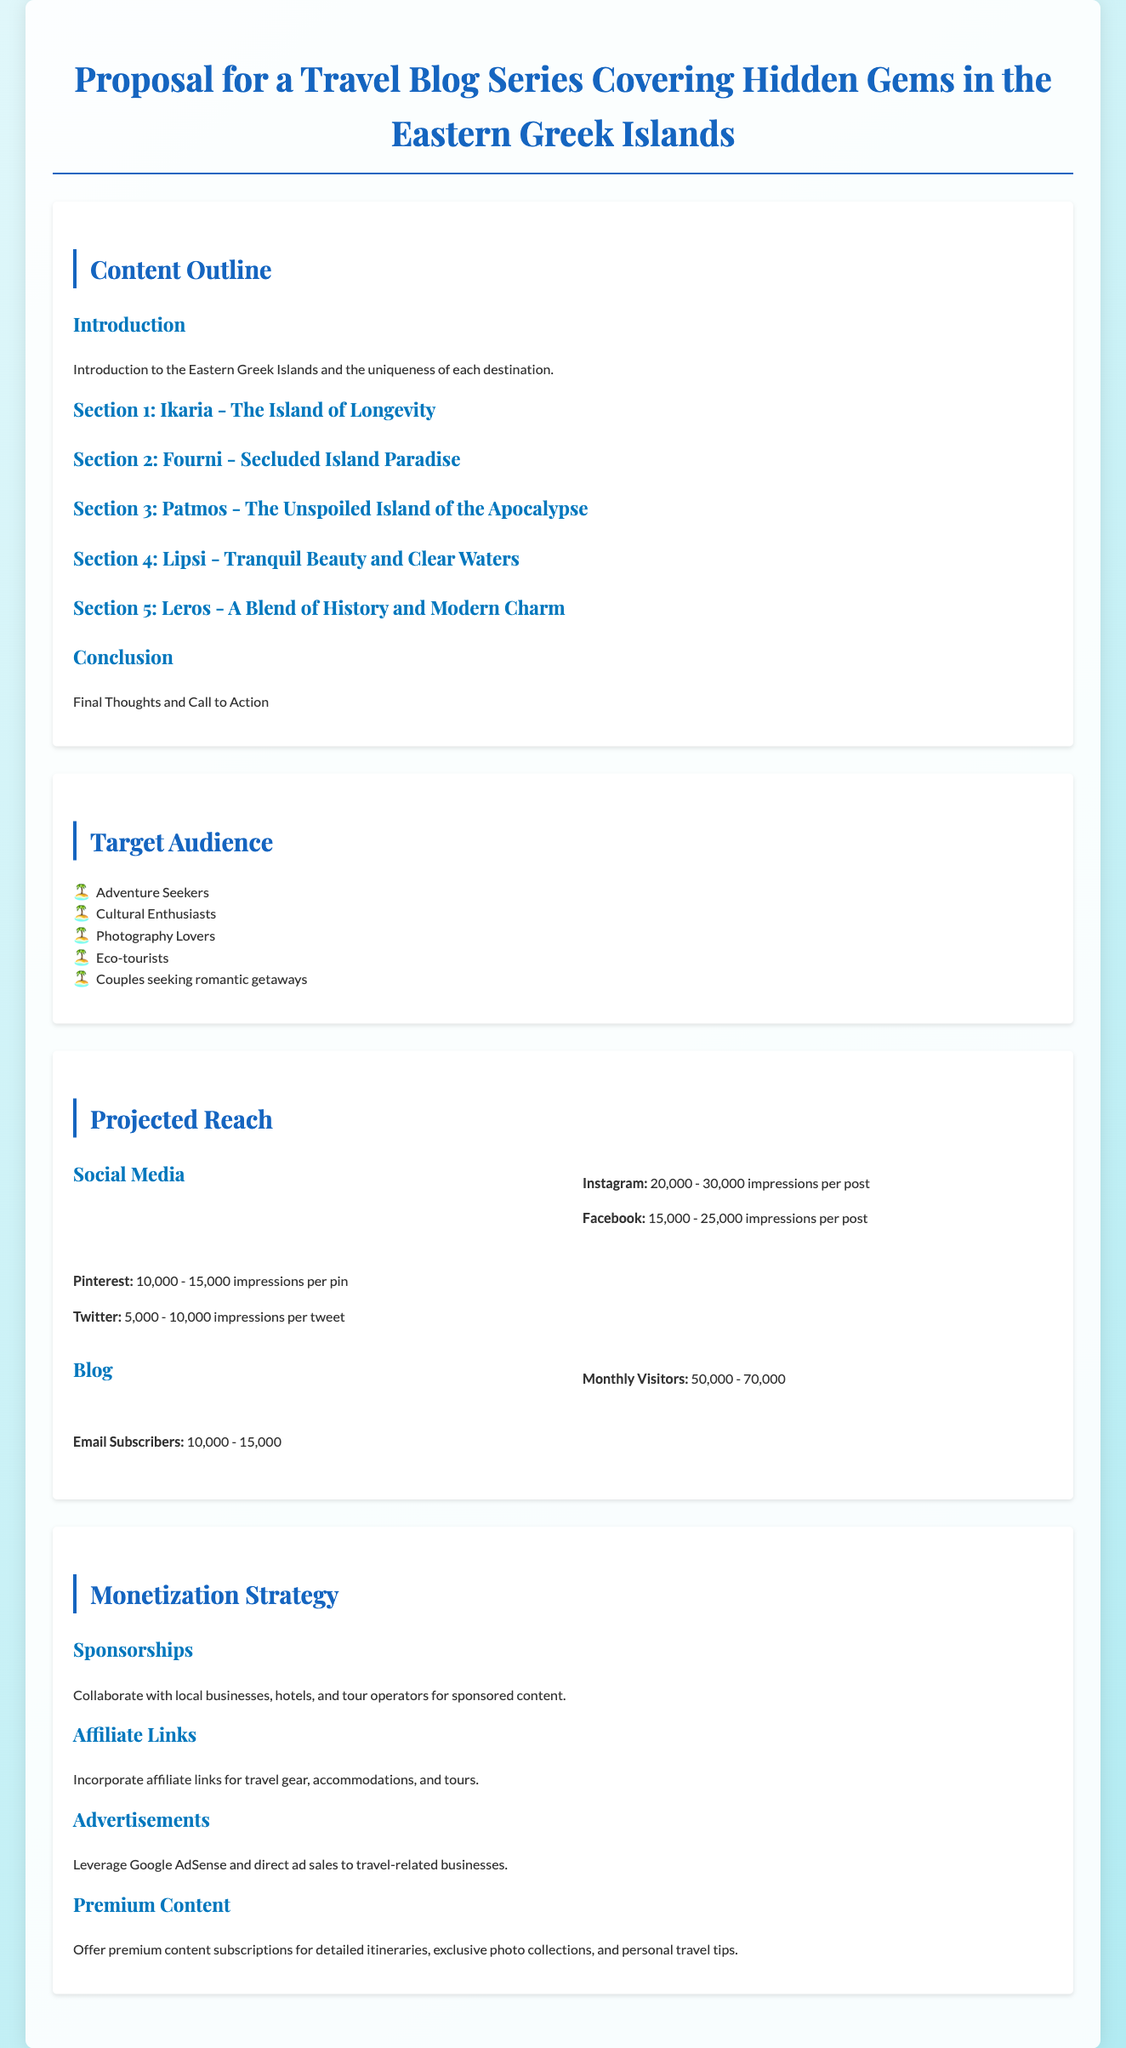What is the title of the proposal? The title of the proposal is stated at the top of the document.
Answer: Proposal for a Travel Blog Series Covering Hidden Gems in the Eastern Greek Islands How many sections are outlined in the content? The content outline includes a total of 5 sections focused on different islands.
Answer: 5 Which island is referred to as "The Island of Longevity"? This specific designation is provided in the section for Ikaria.
Answer: Ikaria Who are the target audiences mentioned in the proposal? The target audience is listed in a bullet format within the document.
Answer: Adventure Seekers, Cultural Enthusiasts, Photography Lovers, Eco-tourists, Couples seeking romantic getaways What is the projected number of monthly visitors to the blog? The monthly visitors are specified in the projected reach section of the document.
Answer: 50,000 - 70,000 What type of monetization strategy involves local businesses? This strategy focuses on partnerships for sponsored content with those businesses.
Answer: Sponsorships Which social media platform is expected to generate the most impressions per post? The expected impressions for each social media platform are outlined, with a specific platform highlighted as highest.
Answer: Instagram What type of content is suggested for premium subscriptions? The proposal outlines what will be offered under premium content subscriptions.
Answer: Detailed itineraries, exclusive photo collections, and personal travel tips 